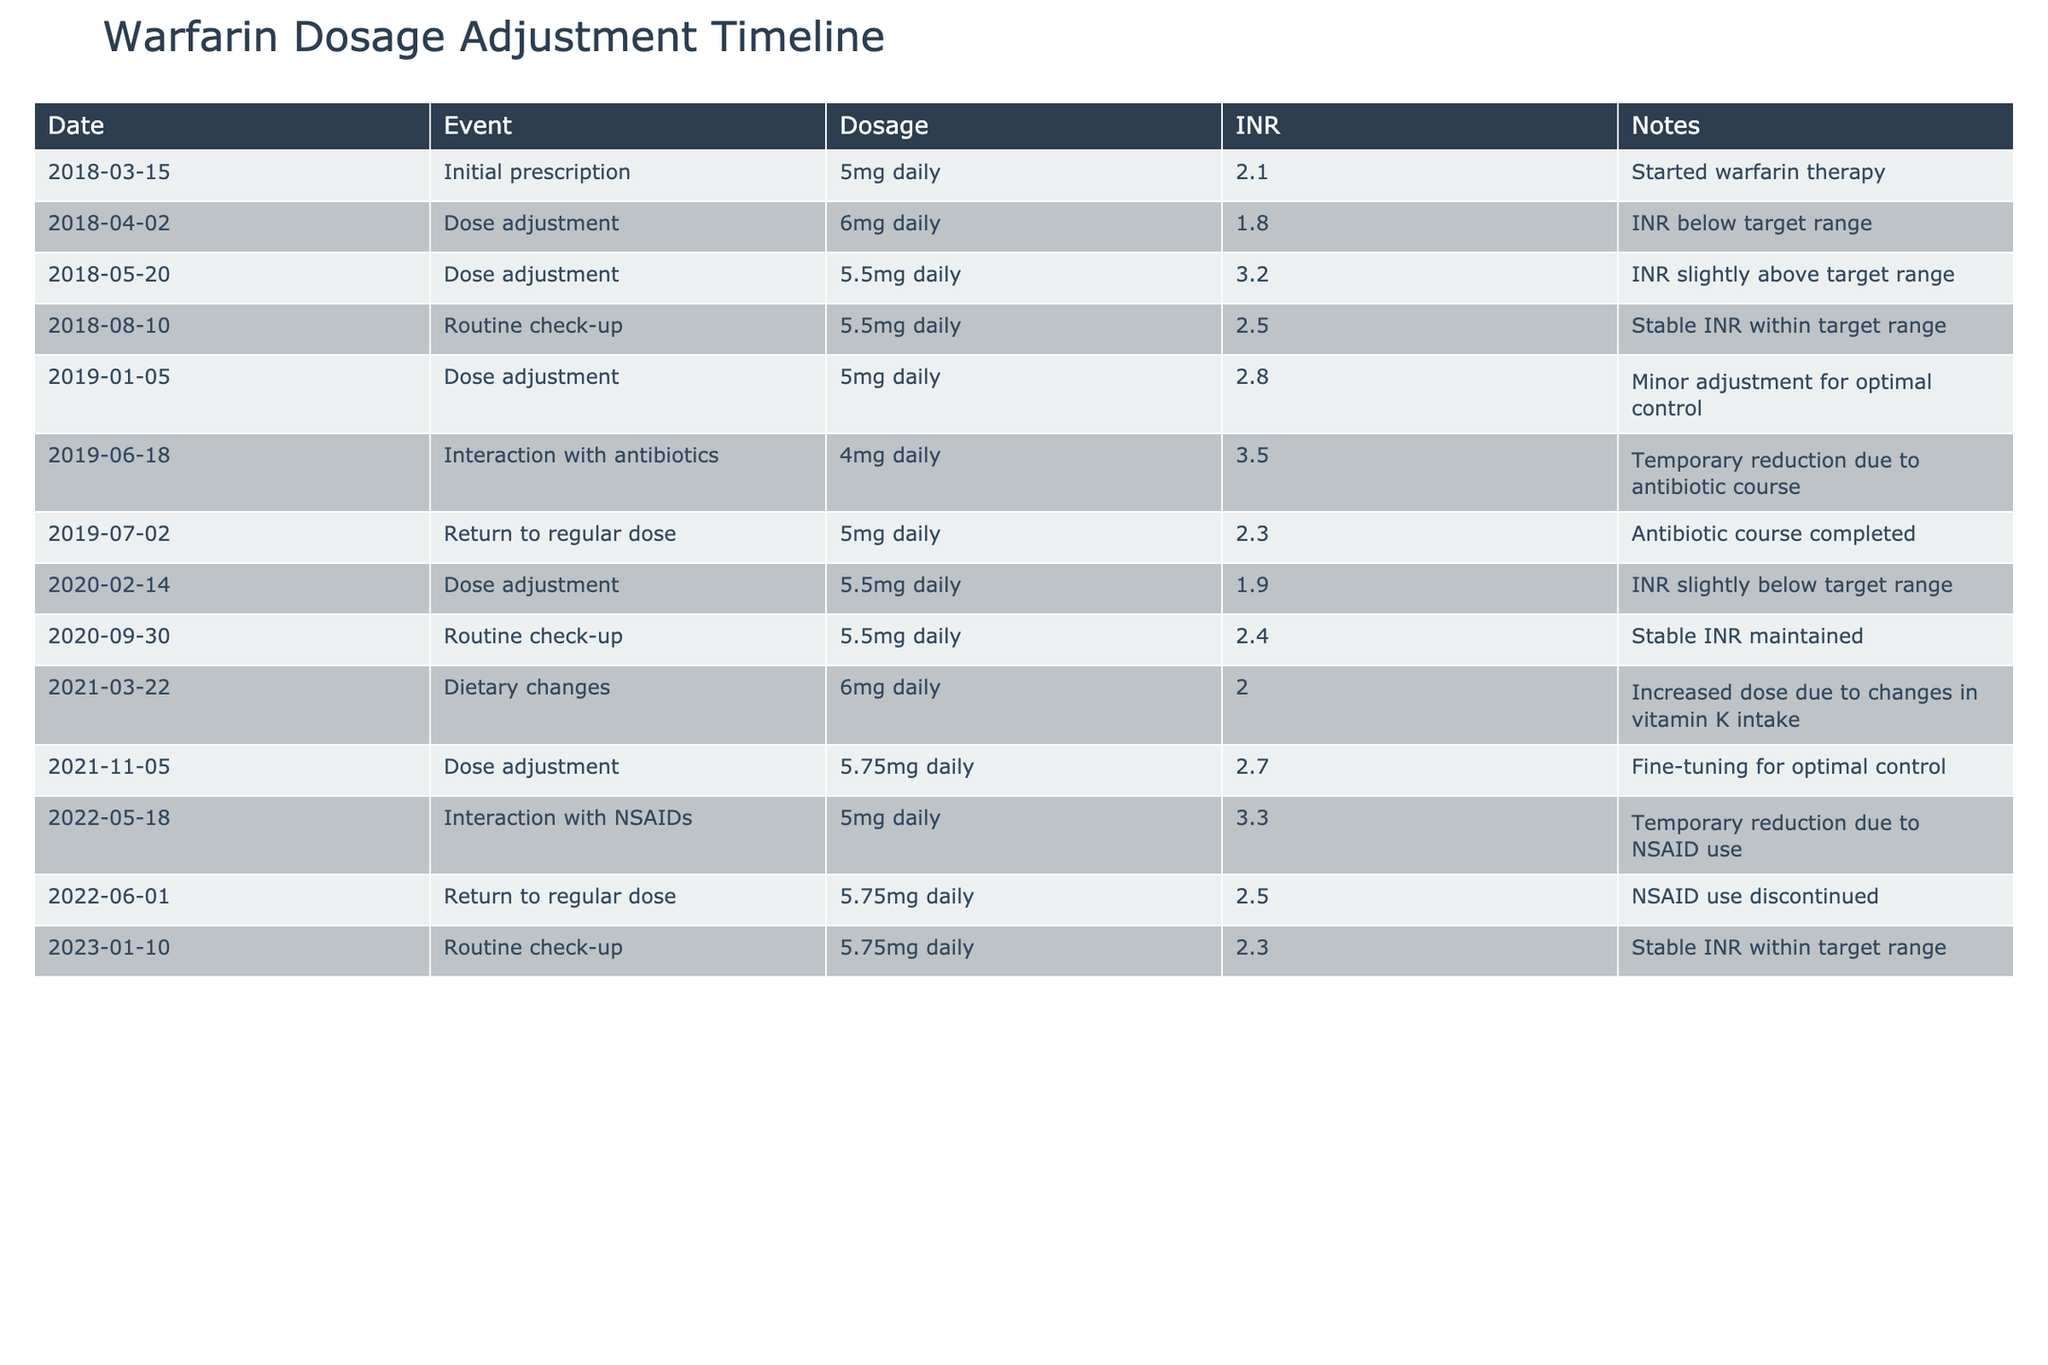What was the initial dosage of warfarin prescribed? The first row of the table shows the initial prescription date of March 15, 2018, with the dosage being 5mg daily.
Answer: 5mg daily What was the INR level on June 18, 2019? Referring to the row dated June 18, 2019, it shows an INR level of 3.5 while the dosage was reduced to 4mg daily due to antibiotic interaction.
Answer: 3.5 How many times was the dosage adjusted throughout the treatment history? By examining the "Event" column, we count the rows where the event is "Dose adjustment." There are six instances marked as dose adjustments.
Answer: 6 Was there ever a time when the INR was below the target range? Checking the "INR" column for values below 2.0, we find that the INR was below the target range on April 2, 2018 (1.8), and on February 14, 2020 (1.9). Thus, the answer is yes.
Answer: Yes What was the average dosage of warfarin after the initial prescription until January 2023? To calculate the average dosage, we take the dosages from all relevant events: 5, 6, 5.5, 5, 4, 5, 5.5, 6, 5.75, 5, 5.75, totaling amounts of 5 + 6 + 5.5 + 5 + 4 + 5 + 5.5 + 6 + 5.75 + 5 + 5.75 = 62.5. There are 11 data points, so the average is 62.5 / 11, which is approximately 5.68.
Answer: Approximately 5.68 How did dietary changes affect the dosage adjustment in March 2021? It is indicated that on March 22, 2021, due to dietary changes that involved increased vitamin K intake, the dosage was raised to 6mg daily. This shows an adjustment in response to diet.
Answer: Increased to 6mg daily 